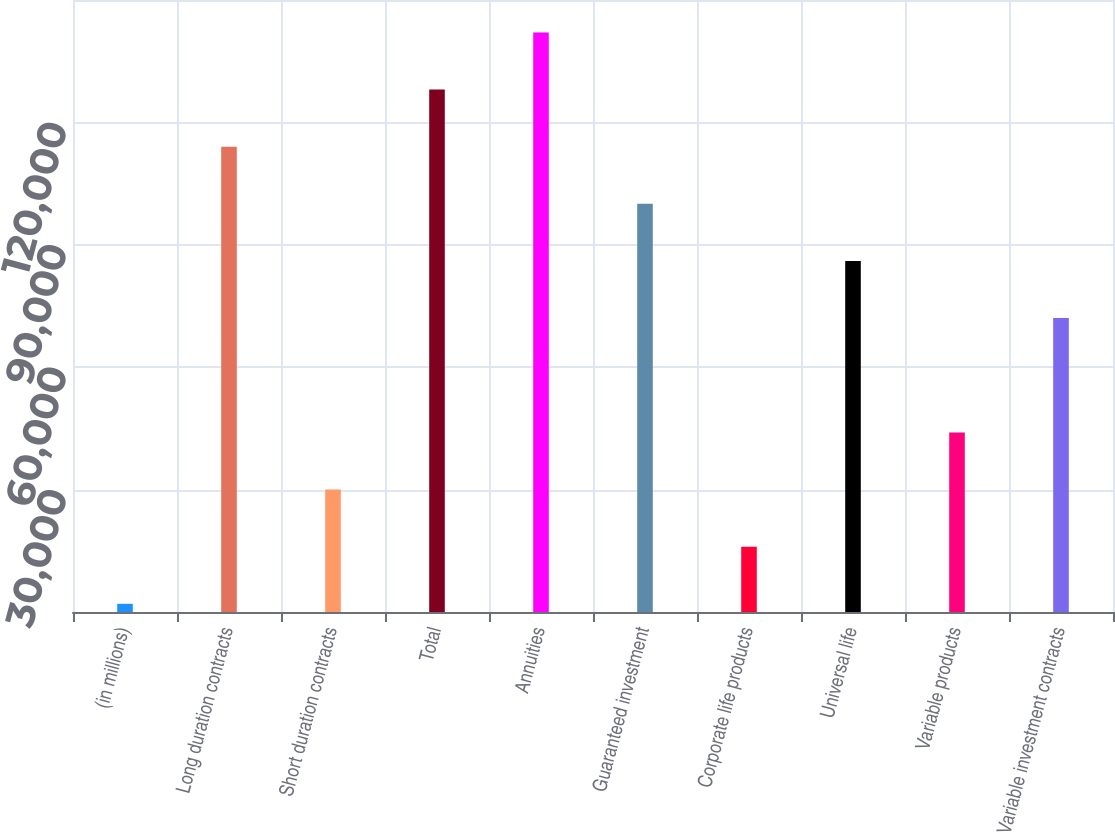Convert chart. <chart><loc_0><loc_0><loc_500><loc_500><bar_chart><fcel>(in millions)<fcel>Long duration contracts<fcel>Short duration contracts<fcel>Total<fcel>Annuities<fcel>Guaranteed investment<fcel>Corporate life products<fcel>Universal life<fcel>Variable products<fcel>Variable investment contracts<nl><fcel>2005<fcel>114047<fcel>30015.4<fcel>128052<fcel>142057<fcel>100041<fcel>16010.2<fcel>86036.2<fcel>44020.6<fcel>72031<nl></chart> 